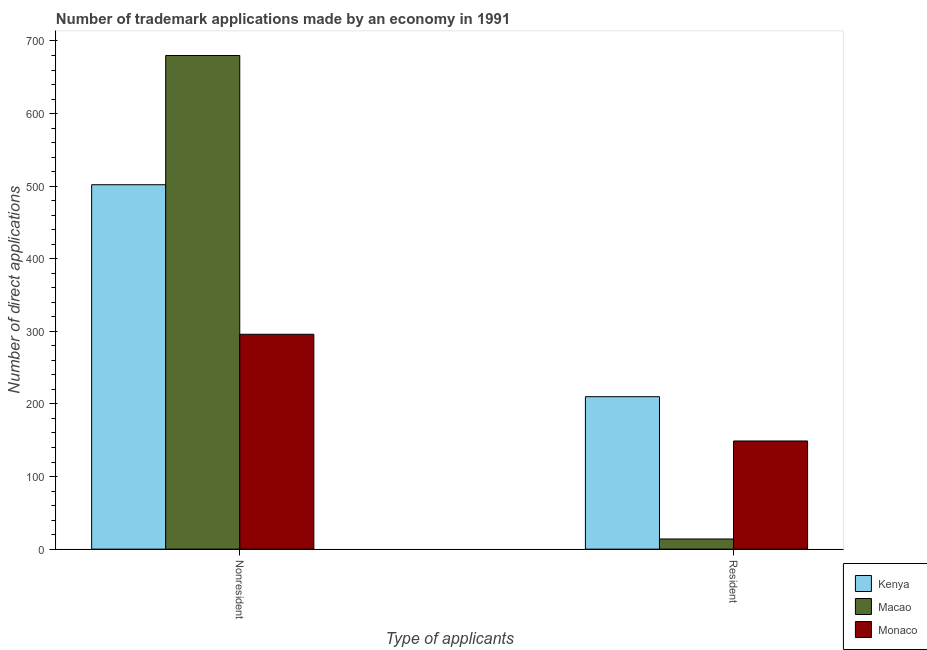How many different coloured bars are there?
Keep it short and to the point. 3. How many groups of bars are there?
Your answer should be compact. 2. Are the number of bars per tick equal to the number of legend labels?
Your response must be concise. Yes. Are the number of bars on each tick of the X-axis equal?
Give a very brief answer. Yes. What is the label of the 1st group of bars from the left?
Your answer should be compact. Nonresident. What is the number of trademark applications made by non residents in Macao?
Provide a short and direct response. 680. Across all countries, what is the maximum number of trademark applications made by non residents?
Make the answer very short. 680. Across all countries, what is the minimum number of trademark applications made by non residents?
Ensure brevity in your answer.  296. In which country was the number of trademark applications made by non residents maximum?
Keep it short and to the point. Macao. In which country was the number of trademark applications made by non residents minimum?
Ensure brevity in your answer.  Monaco. What is the total number of trademark applications made by non residents in the graph?
Provide a succinct answer. 1478. What is the difference between the number of trademark applications made by residents in Monaco and that in Kenya?
Make the answer very short. -61. What is the difference between the number of trademark applications made by residents in Kenya and the number of trademark applications made by non residents in Monaco?
Offer a very short reply. -86. What is the average number of trademark applications made by residents per country?
Make the answer very short. 124.33. What is the difference between the number of trademark applications made by non residents and number of trademark applications made by residents in Monaco?
Offer a terse response. 147. What is the ratio of the number of trademark applications made by non residents in Monaco to that in Macao?
Ensure brevity in your answer.  0.44. In how many countries, is the number of trademark applications made by residents greater than the average number of trademark applications made by residents taken over all countries?
Ensure brevity in your answer.  2. What does the 3rd bar from the left in Nonresident represents?
Offer a very short reply. Monaco. What does the 1st bar from the right in Resident represents?
Keep it short and to the point. Monaco. How many countries are there in the graph?
Ensure brevity in your answer.  3. What is the difference between two consecutive major ticks on the Y-axis?
Your answer should be very brief. 100. Are the values on the major ticks of Y-axis written in scientific E-notation?
Your answer should be very brief. No. Does the graph contain any zero values?
Your answer should be very brief. No. Where does the legend appear in the graph?
Make the answer very short. Bottom right. How many legend labels are there?
Keep it short and to the point. 3. What is the title of the graph?
Your response must be concise. Number of trademark applications made by an economy in 1991. What is the label or title of the X-axis?
Provide a short and direct response. Type of applicants. What is the label or title of the Y-axis?
Keep it short and to the point. Number of direct applications. What is the Number of direct applications in Kenya in Nonresident?
Give a very brief answer. 502. What is the Number of direct applications of Macao in Nonresident?
Provide a short and direct response. 680. What is the Number of direct applications of Monaco in Nonresident?
Make the answer very short. 296. What is the Number of direct applications of Kenya in Resident?
Ensure brevity in your answer.  210. What is the Number of direct applications of Macao in Resident?
Give a very brief answer. 14. What is the Number of direct applications in Monaco in Resident?
Provide a short and direct response. 149. Across all Type of applicants, what is the maximum Number of direct applications in Kenya?
Keep it short and to the point. 502. Across all Type of applicants, what is the maximum Number of direct applications of Macao?
Your response must be concise. 680. Across all Type of applicants, what is the maximum Number of direct applications in Monaco?
Your response must be concise. 296. Across all Type of applicants, what is the minimum Number of direct applications of Kenya?
Keep it short and to the point. 210. Across all Type of applicants, what is the minimum Number of direct applications of Macao?
Give a very brief answer. 14. Across all Type of applicants, what is the minimum Number of direct applications of Monaco?
Give a very brief answer. 149. What is the total Number of direct applications of Kenya in the graph?
Ensure brevity in your answer.  712. What is the total Number of direct applications of Macao in the graph?
Your answer should be compact. 694. What is the total Number of direct applications in Monaco in the graph?
Provide a succinct answer. 445. What is the difference between the Number of direct applications in Kenya in Nonresident and that in Resident?
Give a very brief answer. 292. What is the difference between the Number of direct applications of Macao in Nonresident and that in Resident?
Your response must be concise. 666. What is the difference between the Number of direct applications in Monaco in Nonresident and that in Resident?
Make the answer very short. 147. What is the difference between the Number of direct applications of Kenya in Nonresident and the Number of direct applications of Macao in Resident?
Ensure brevity in your answer.  488. What is the difference between the Number of direct applications in Kenya in Nonresident and the Number of direct applications in Monaco in Resident?
Your answer should be very brief. 353. What is the difference between the Number of direct applications of Macao in Nonresident and the Number of direct applications of Monaco in Resident?
Provide a short and direct response. 531. What is the average Number of direct applications in Kenya per Type of applicants?
Provide a short and direct response. 356. What is the average Number of direct applications in Macao per Type of applicants?
Your response must be concise. 347. What is the average Number of direct applications in Monaco per Type of applicants?
Your response must be concise. 222.5. What is the difference between the Number of direct applications of Kenya and Number of direct applications of Macao in Nonresident?
Your response must be concise. -178. What is the difference between the Number of direct applications in Kenya and Number of direct applications in Monaco in Nonresident?
Your answer should be compact. 206. What is the difference between the Number of direct applications of Macao and Number of direct applications of Monaco in Nonresident?
Keep it short and to the point. 384. What is the difference between the Number of direct applications in Kenya and Number of direct applications in Macao in Resident?
Provide a short and direct response. 196. What is the difference between the Number of direct applications of Kenya and Number of direct applications of Monaco in Resident?
Keep it short and to the point. 61. What is the difference between the Number of direct applications of Macao and Number of direct applications of Monaco in Resident?
Provide a short and direct response. -135. What is the ratio of the Number of direct applications in Kenya in Nonresident to that in Resident?
Keep it short and to the point. 2.39. What is the ratio of the Number of direct applications in Macao in Nonresident to that in Resident?
Your answer should be very brief. 48.57. What is the ratio of the Number of direct applications of Monaco in Nonresident to that in Resident?
Keep it short and to the point. 1.99. What is the difference between the highest and the second highest Number of direct applications of Kenya?
Offer a terse response. 292. What is the difference between the highest and the second highest Number of direct applications in Macao?
Make the answer very short. 666. What is the difference between the highest and the second highest Number of direct applications of Monaco?
Provide a short and direct response. 147. What is the difference between the highest and the lowest Number of direct applications in Kenya?
Your response must be concise. 292. What is the difference between the highest and the lowest Number of direct applications of Macao?
Your answer should be very brief. 666. What is the difference between the highest and the lowest Number of direct applications in Monaco?
Give a very brief answer. 147. 